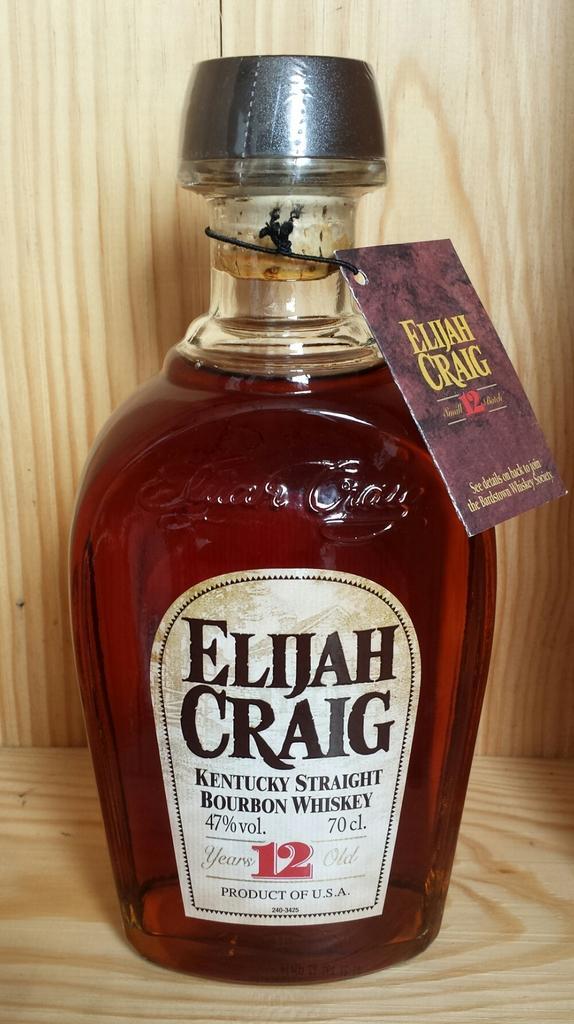Describe this image in one or two sentences. In this image i can see a glass bottle with a name "Elijah Craig" on it. 